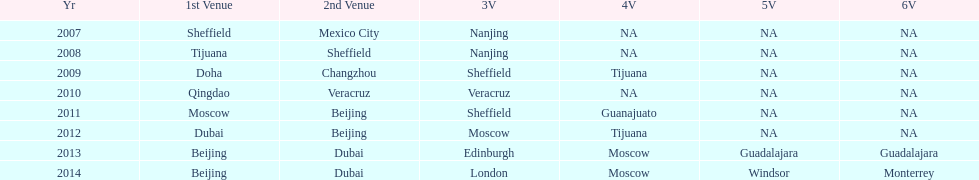How long, in years, has the this world series been occurring? 7 years. 